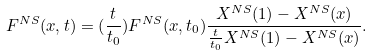<formula> <loc_0><loc_0><loc_500><loc_500>F ^ { N S } ( x , t ) = ( \frac { t } { t _ { 0 } } ) F ^ { N S } ( x , t _ { 0 } ) \frac { X ^ { N S } ( 1 ) - X ^ { N S } ( x ) } { \frac { t } { t _ { 0 } } X ^ { N S } ( 1 ) - X ^ { N S } ( x ) } .</formula> 